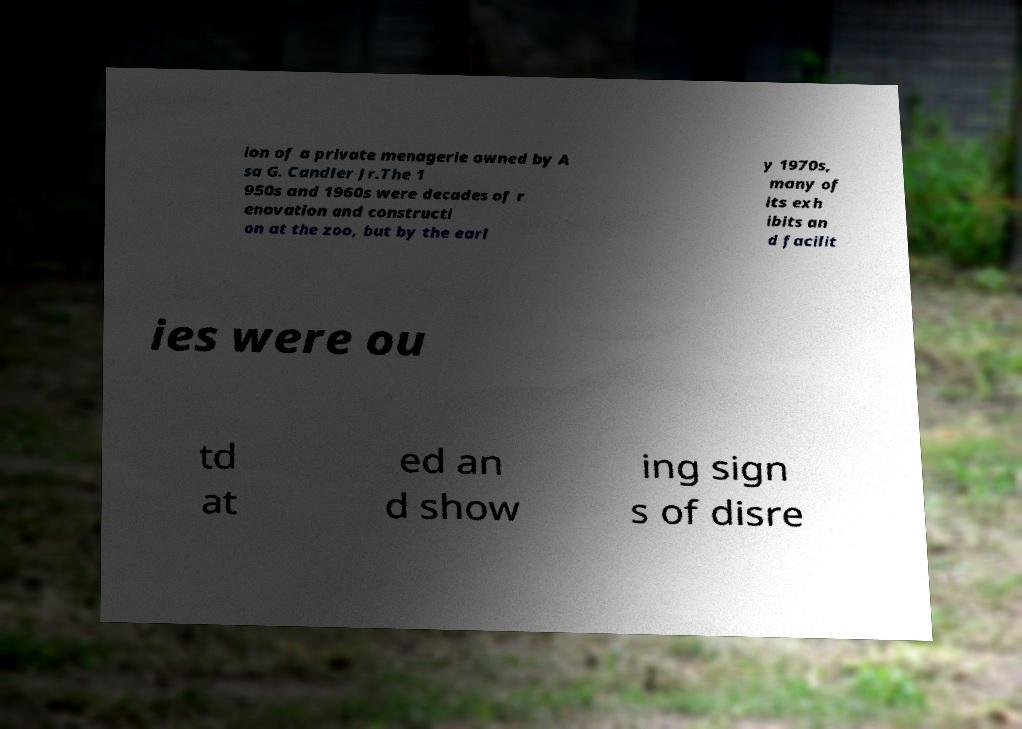For documentation purposes, I need the text within this image transcribed. Could you provide that? ion of a private menagerie owned by A sa G. Candler Jr.The 1 950s and 1960s were decades of r enovation and constructi on at the zoo, but by the earl y 1970s, many of its exh ibits an d facilit ies were ou td at ed an d show ing sign s of disre 